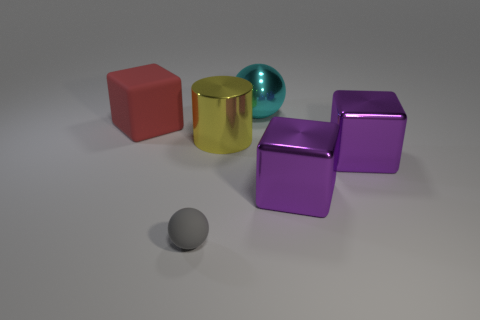Subtract all red blocks. How many blocks are left? 2 Add 1 large metallic blocks. How many objects exist? 7 Subtract 1 cubes. How many cubes are left? 2 Subtract all spheres. How many objects are left? 4 Subtract all small objects. Subtract all large purple metal blocks. How many objects are left? 3 Add 6 gray things. How many gray things are left? 7 Add 3 large cyan shiny balls. How many large cyan shiny balls exist? 4 Subtract all gray balls. How many balls are left? 1 Subtract 1 cyan spheres. How many objects are left? 5 Subtract all cyan cylinders. Subtract all cyan cubes. How many cylinders are left? 1 